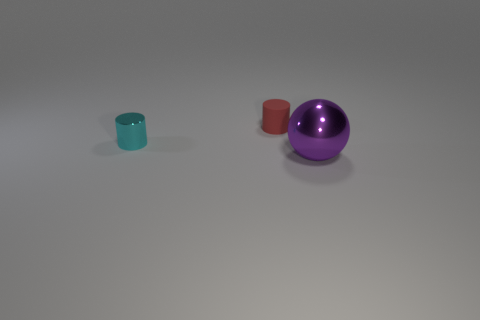Does the small red thing have the same material as the cyan object?
Your answer should be very brief. No. Is the number of small metal cylinders less than the number of tiny cyan rubber cylinders?
Your answer should be compact. No. Does the big purple object have the same shape as the small red rubber object?
Your answer should be compact. No. What color is the small matte object?
Give a very brief answer. Red. How many other objects are there of the same material as the red cylinder?
Provide a short and direct response. 0. What number of gray objects are large shiny spheres or small metal cylinders?
Your response must be concise. 0. There is a shiny object behind the metal sphere; is its shape the same as the small thing that is behind the tiny shiny thing?
Your answer should be very brief. Yes. Does the tiny shiny cylinder have the same color as the thing that is right of the tiny red rubber object?
Provide a succinct answer. No. There is a cylinder behind the small shiny thing; is its color the same as the metallic sphere?
Provide a short and direct response. No. How many objects are either big cyan spheres or objects behind the large object?
Your answer should be very brief. 2. 